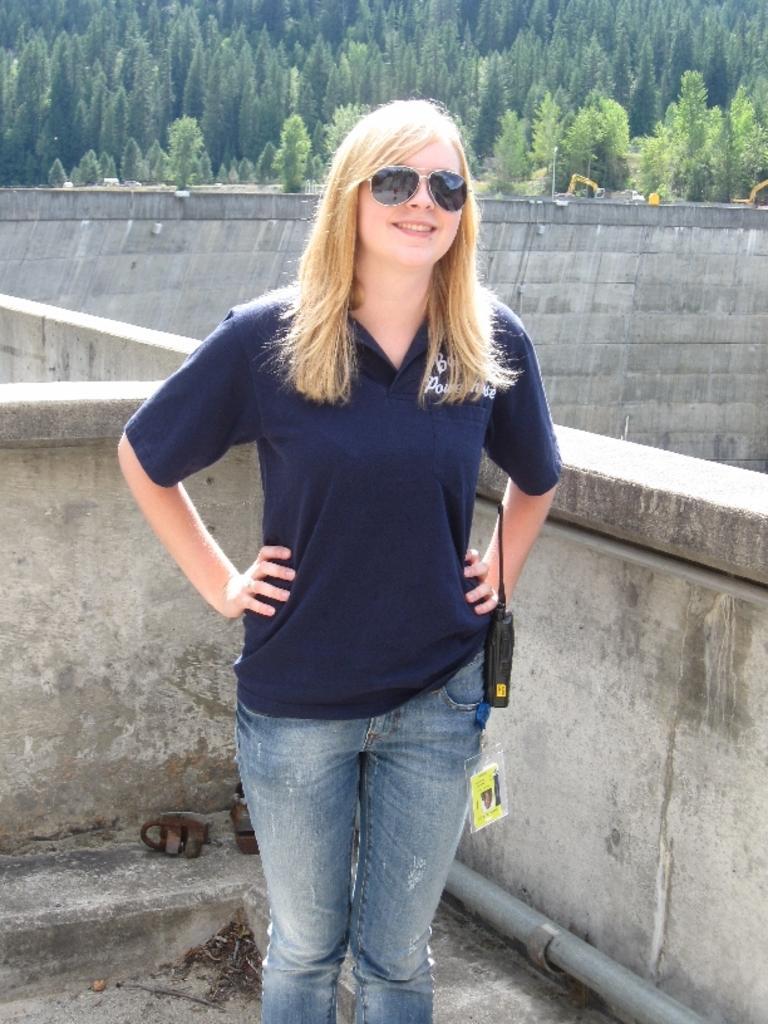Please provide a concise description of this image. This picture is clicked outside. In the center we can see a woman wearing t-shirt, googles, smiling and standing. In the background we can see a pipe and the some other objects and we can see the guard rail and we can see the trees, wall and some other objects. 